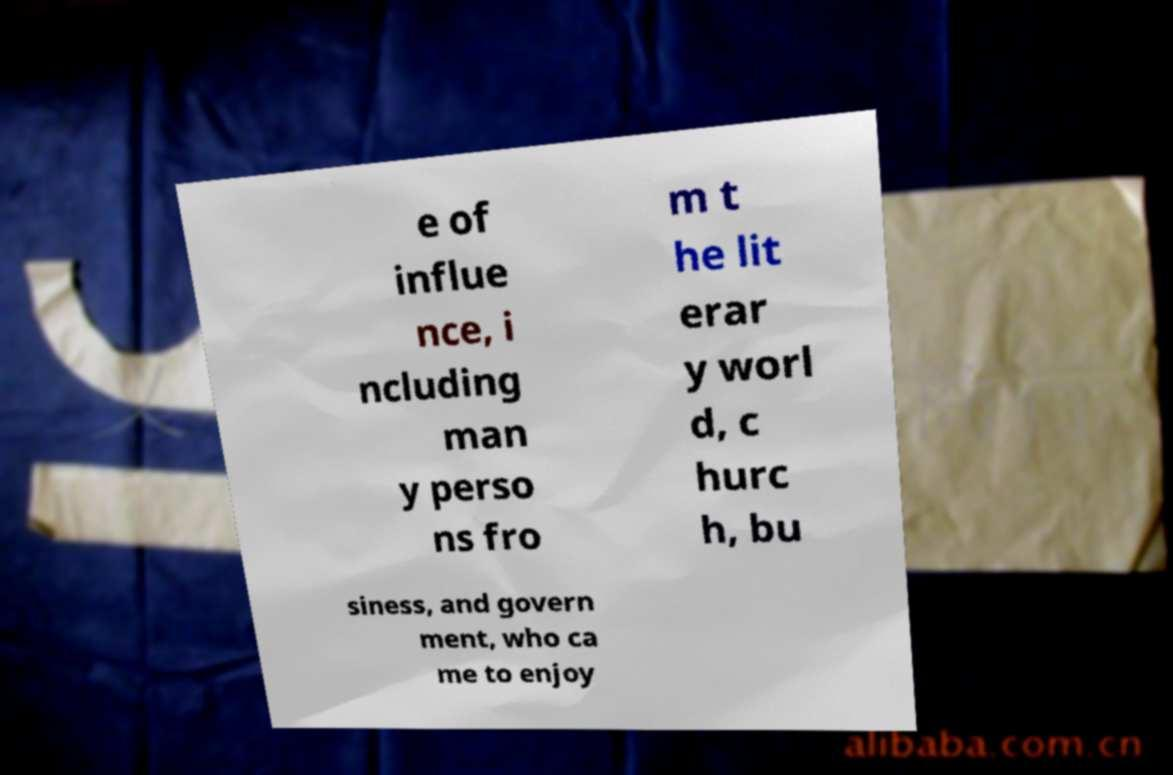Please identify and transcribe the text found in this image. e of influe nce, i ncluding man y perso ns fro m t he lit erar y worl d, c hurc h, bu siness, and govern ment, who ca me to enjoy 